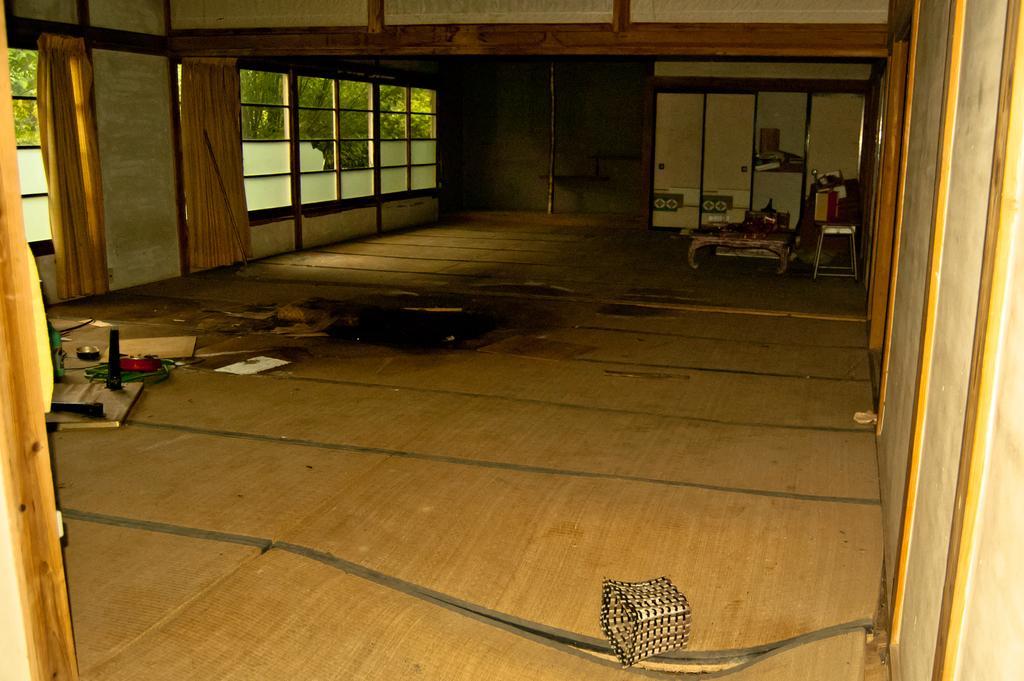How would you summarize this image in a sentence or two? In this picture we can see table, stool and objects on wooden floor. We can see curtains, cupboards and glass windows, through glass windows we can see leaves. 